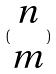Convert formula to latex. <formula><loc_0><loc_0><loc_500><loc_500>( \begin{matrix} n \\ m \end{matrix} )</formula> 